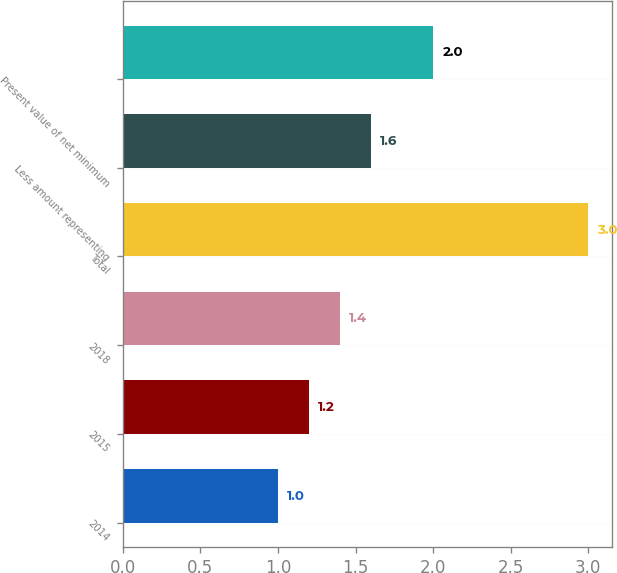Convert chart to OTSL. <chart><loc_0><loc_0><loc_500><loc_500><bar_chart><fcel>2014<fcel>2015<fcel>2018<fcel>Total<fcel>Less amount representing<fcel>Present value of net minimum<nl><fcel>1<fcel>1.2<fcel>1.4<fcel>3<fcel>1.6<fcel>2<nl></chart> 